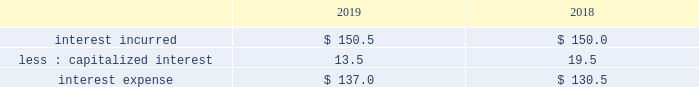Interest expense .
Interest incurred increased $ .5 as interest expense associated with financing the lu'an joint venture was mostly offset by favorable impacts from currency , a lower average interest rate on the debt portfolio , and a lower average debt balance .
Capitalized interest decreased 31% ( 31 % ) , or $ 6.0 , due to a decrease in the carrying value of projects under construction , primarily driven by the lu'an project in asia .
Other non-operating income ( expense ) , net other non-operating income ( expense ) , net of $ 66.7 increased $ 61.6 , primarily due to lower pension settlement losses , higher non-service pension income , and higher interest income on cash and cash items .
The prior year included pension settlement losses of $ 43.7 ( $ 33.2 after-tax , or $ .15 per share ) primarily in connection with the transfer of certain pension assets and payment obligations to an insurer for our u.s .
Salaried and hourly plans .
In fiscal year 2019 , we recognized a pension settlement loss of $ 5.0 ( $ 3.8 after-tax , or $ .02 per share ) associated with the u.s .
Supplementary pension plan during the second quarter .
Net income and net income margin net income of $ 1809.4 increased 18% ( 18 % ) , or $ 276.5 , primarily due to impacts from the u.s .
Tax cuts and jobs act , positive pricing , and favorable volumes .
Net income margin of 20.3% ( 20.3 % ) increased 310 bp .
Adjusted ebitda and adjusted ebitda margin adjusted ebitda of $ 3468.0 increased 11% ( 11 % ) , or $ 352.5 , primarily due to positive pricing and higher volumes , partially offset by unfavorable currency .
Adjusted ebitda margin of 38.9% ( 38.9 % ) increased 400 bp , primarily due to higher volumes , positive pricing , and the india contract modification .
The india contract modification contributed 80 bp .
Effective tax rate the effective tax rate equals the income tax provision divided by income from continuing operations before taxes .
The effective tax rate was 21.0% ( 21.0 % ) and 26.0% ( 26.0 % ) in fiscal years 2019 and 2018 , respectively .
The current year rate was lower primarily due to impacts related to the enactment of the u.s .
Tax cuts and jobs act ( the 201ctax act" ) in 2018 , which significantly changed existing u.s .
Tax laws , including a reduction in the federal corporate income tax rate from 35% ( 35 % ) to 21% ( 21 % ) , a deemed repatriation tax on unremitted foreign earnings , as well as other changes .
As a result of the tax act , our income tax provision reflects discrete net income tax costs of $ 43.8 and $ 180.6 in fiscal years 2019 and 2018 , respectively .
The current year included a cost of $ 56.2 ( $ .26 per share ) for the reversal of a benefit recorded in 2018 related to the u.s .
Taxation of deemed foreign dividends .
We recorded this reversal based on regulations issued in 2019 .
The 2019 reversal was partially offset by a favorable adjustment of $ 12.4 ( $ .06 per share ) that was recorded as we completed our estimates of the impacts of the tax act .
This adjustment is primarily related to foreign tax items , including the deemed repatriation tax for foreign tax redeterminations .
In addition , the current year rate included a net gain on the exchange of two equity affiliates of $ 29.1 , which was not a taxable transaction .
The higher 2018 expense resulting from the tax act was partially offset by a $ 35.7 tax benefit from the restructuring of foreign subsidiaries , a $ 9.1 benefit from a foreign audit settlement agreement , and higher excess tax benefits on share-based compensation .
The adjusted effective tax rate was 19.4% ( 19.4 % ) and 18.6% ( 18.6 % ) in fiscal years 2019 and 2018 , respectively .
The lower prior year rate was primarily due to the $ 9.1 benefit from a foreign audit settlement agreement and higher excess tax benefits on share-based compensation. .
What is the variation of the adjusted effective tax rate considering the years 2018-2019? 
Rationale: it is the difference between those adjusted effective tax rates during these years .
Computations: (19.4% - 18.6%)
Answer: 0.008. 